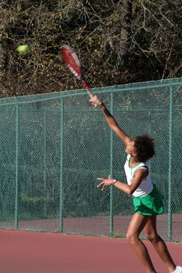Describe the objects in this image and their specific colors. I can see people in black, brown, gray, and maroon tones, tennis racket in black, maroon, brown, and darkgray tones, and sports ball in black, olive, and khaki tones in this image. 